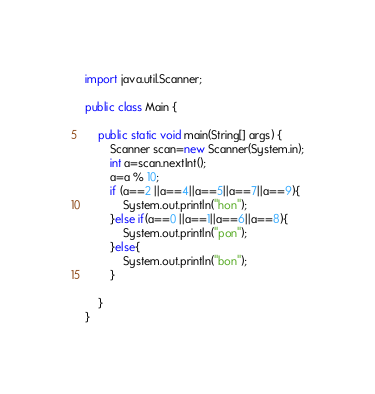Convert code to text. <code><loc_0><loc_0><loc_500><loc_500><_Java_>import java.util.Scanner;

public class Main {

    public static void main(String[] args) {
        Scanner scan=new Scanner(System.in);
        int a=scan.nextInt();
        a=a % 10;
        if (a==2 ||a==4||a==5||a==7||a==9){
            System.out.println("hon");
        }else if(a==0 ||a==1||a==6||a==8){
            System.out.println("pon");
        }else{
            System.out.println("bon");
        }

    }
}</code> 